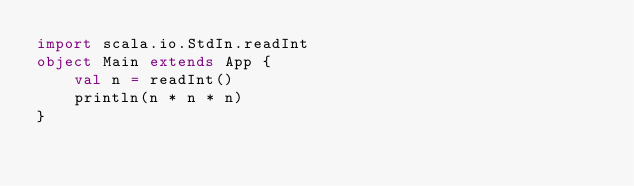<code> <loc_0><loc_0><loc_500><loc_500><_Scala_>import scala.io.StdIn.readInt
object Main extends App {
    val n = readInt()
    println(n * n * n)
}
</code> 